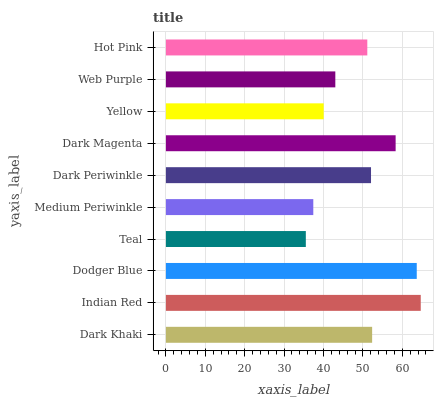Is Teal the minimum?
Answer yes or no. Yes. Is Indian Red the maximum?
Answer yes or no. Yes. Is Dodger Blue the minimum?
Answer yes or no. No. Is Dodger Blue the maximum?
Answer yes or no. No. Is Indian Red greater than Dodger Blue?
Answer yes or no. Yes. Is Dodger Blue less than Indian Red?
Answer yes or no. Yes. Is Dodger Blue greater than Indian Red?
Answer yes or no. No. Is Indian Red less than Dodger Blue?
Answer yes or no. No. Is Dark Periwinkle the high median?
Answer yes or no. Yes. Is Hot Pink the low median?
Answer yes or no. Yes. Is Indian Red the high median?
Answer yes or no. No. Is Dodger Blue the low median?
Answer yes or no. No. 